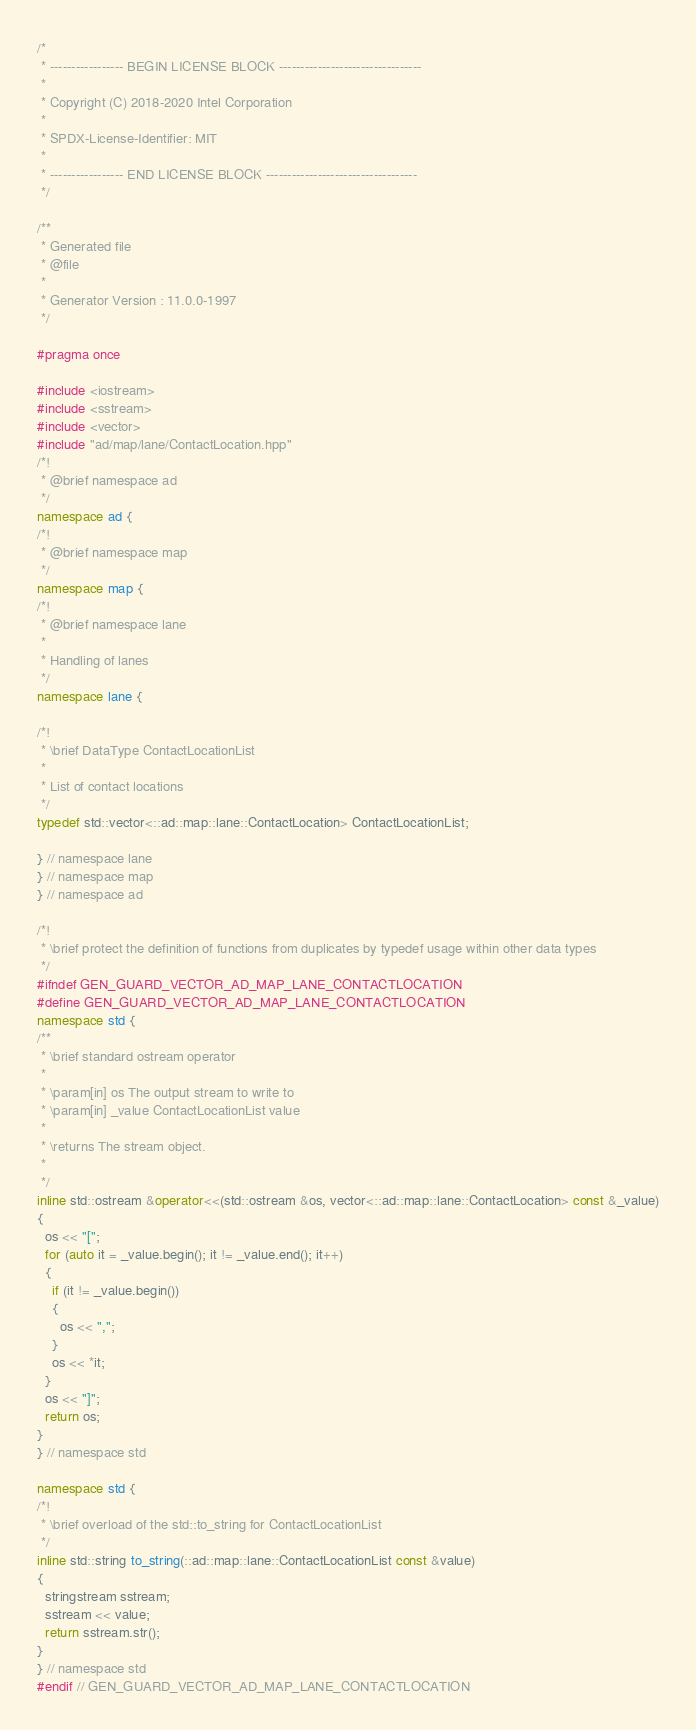<code> <loc_0><loc_0><loc_500><loc_500><_C++_>/*
 * ----------------- BEGIN LICENSE BLOCK ---------------------------------
 *
 * Copyright (C) 2018-2020 Intel Corporation
 *
 * SPDX-License-Identifier: MIT
 *
 * ----------------- END LICENSE BLOCK -----------------------------------
 */

/**
 * Generated file
 * @file
 *
 * Generator Version : 11.0.0-1997
 */

#pragma once

#include <iostream>
#include <sstream>
#include <vector>
#include "ad/map/lane/ContactLocation.hpp"
/*!
 * @brief namespace ad
 */
namespace ad {
/*!
 * @brief namespace map
 */
namespace map {
/*!
 * @brief namespace lane
 *
 * Handling of lanes
 */
namespace lane {

/*!
 * \brief DataType ContactLocationList
 *
 * List of contact locations
 */
typedef std::vector<::ad::map::lane::ContactLocation> ContactLocationList;

} // namespace lane
} // namespace map
} // namespace ad

/*!
 * \brief protect the definition of functions from duplicates by typedef usage within other data types
 */
#ifndef GEN_GUARD_VECTOR_AD_MAP_LANE_CONTACTLOCATION
#define GEN_GUARD_VECTOR_AD_MAP_LANE_CONTACTLOCATION
namespace std {
/**
 * \brief standard ostream operator
 *
 * \param[in] os The output stream to write to
 * \param[in] _value ContactLocationList value
 *
 * \returns The stream object.
 *
 */
inline std::ostream &operator<<(std::ostream &os, vector<::ad::map::lane::ContactLocation> const &_value)
{
  os << "[";
  for (auto it = _value.begin(); it != _value.end(); it++)
  {
    if (it != _value.begin())
    {
      os << ",";
    }
    os << *it;
  }
  os << "]";
  return os;
}
} // namespace std

namespace std {
/*!
 * \brief overload of the std::to_string for ContactLocationList
 */
inline std::string to_string(::ad::map::lane::ContactLocationList const &value)
{
  stringstream sstream;
  sstream << value;
  return sstream.str();
}
} // namespace std
#endif // GEN_GUARD_VECTOR_AD_MAP_LANE_CONTACTLOCATION
</code> 